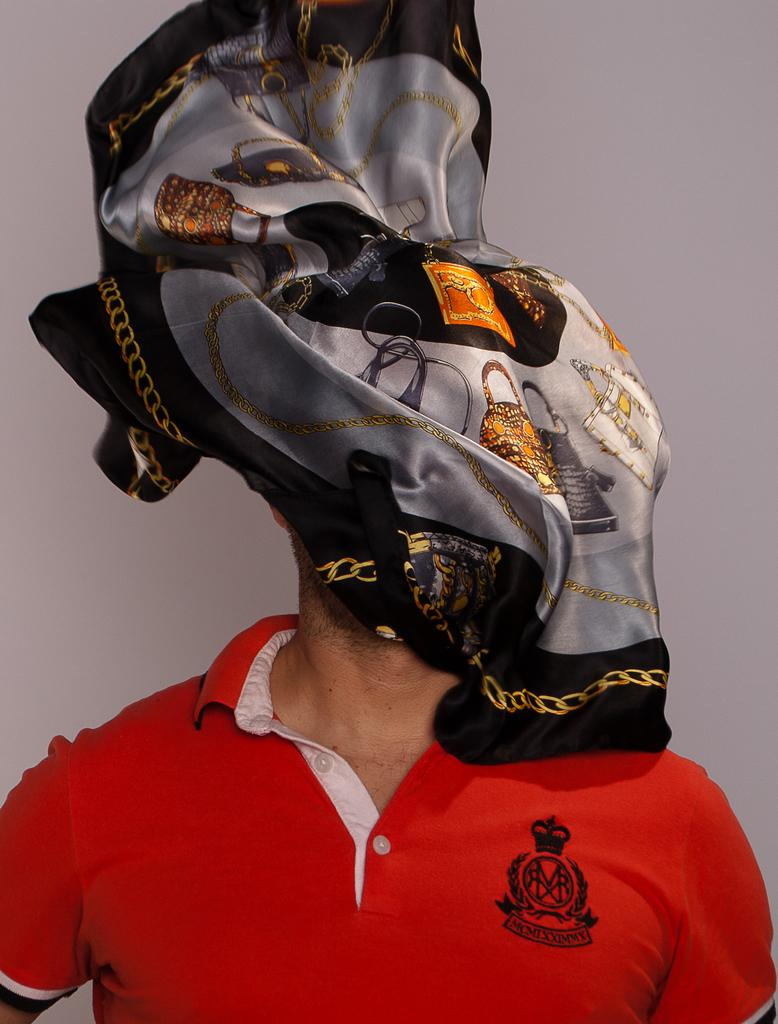Who is present in the image? There is a man in the image. What is the man wearing? The man is wearing a red t-shirt. Can you describe the man's face in the image? There is a cloth covering the man's face. What can be seen in the background of the image? There is a wall in the background of the image. What type of oatmeal is the man eating in the image? There is no oatmeal present in the image, and the man is not eating anything. What fact can be learned about the man's height from the image? The image does not provide any information about the man's height, so we cannot determine a fact about it. 